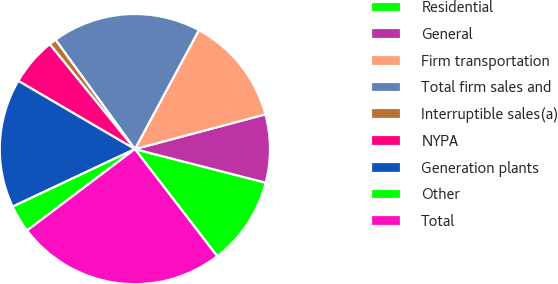Convert chart to OTSL. <chart><loc_0><loc_0><loc_500><loc_500><pie_chart><fcel>Residential<fcel>General<fcel>Firm transportation<fcel>Total firm sales and<fcel>Interruptible sales(a)<fcel>NYPA<fcel>Generation plants<fcel>Other<fcel>Total<nl><fcel>10.57%<fcel>8.14%<fcel>13.0%<fcel>17.85%<fcel>0.86%<fcel>5.72%<fcel>15.43%<fcel>3.29%<fcel>25.14%<nl></chart> 